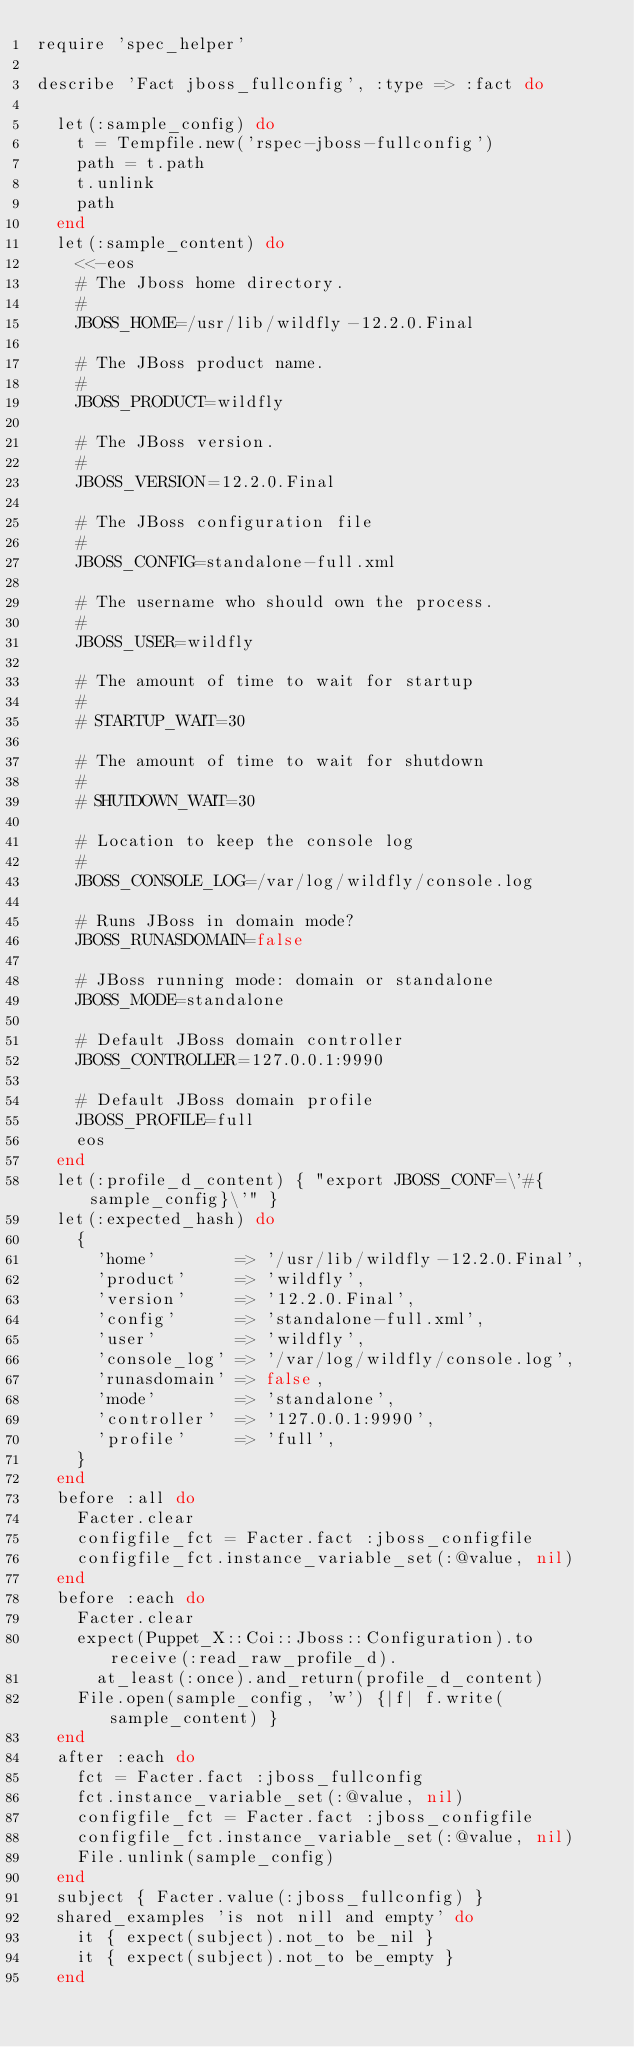<code> <loc_0><loc_0><loc_500><loc_500><_Ruby_>require 'spec_helper'

describe 'Fact jboss_fullconfig', :type => :fact do

  let(:sample_config) do
    t = Tempfile.new('rspec-jboss-fullconfig')
    path = t.path
    t.unlink
    path
  end
  let(:sample_content) do
    <<-eos
    # The Jboss home directory.
    #
    JBOSS_HOME=/usr/lib/wildfly-12.2.0.Final

    # The JBoss product name.
    #
    JBOSS_PRODUCT=wildfly

    # The JBoss version.
    #
    JBOSS_VERSION=12.2.0.Final

    # The JBoss configuration file
    #
    JBOSS_CONFIG=standalone-full.xml

    # The username who should own the process.
    #
    JBOSS_USER=wildfly

    # The amount of time to wait for startup
    #
    # STARTUP_WAIT=30

    # The amount of time to wait for shutdown
    #
    # SHUTDOWN_WAIT=30

    # Location to keep the console log
    #
    JBOSS_CONSOLE_LOG=/var/log/wildfly/console.log

    # Runs JBoss in domain mode?
    JBOSS_RUNASDOMAIN=false

    # JBoss running mode: domain or standalone
    JBOSS_MODE=standalone

    # Default JBoss domain controller
    JBOSS_CONTROLLER=127.0.0.1:9990

    # Default JBoss domain profile
    JBOSS_PROFILE=full
    eos
  end
  let(:profile_d_content) { "export JBOSS_CONF=\'#{sample_config}\'" }
  let(:expected_hash) do
    {
      'home'        => '/usr/lib/wildfly-12.2.0.Final',
      'product'     => 'wildfly',
      'version'     => '12.2.0.Final',
      'config'      => 'standalone-full.xml',
      'user'        => 'wildfly',
      'console_log' => '/var/log/wildfly/console.log',
      'runasdomain' => false,
      'mode'        => 'standalone',
      'controller'  => '127.0.0.1:9990',
      'profile'     => 'full',
    }
  end
  before :all do
    Facter.clear
    configfile_fct = Facter.fact :jboss_configfile
    configfile_fct.instance_variable_set(:@value, nil)
  end
  before :each do
    Facter.clear
    expect(Puppet_X::Coi::Jboss::Configuration).to receive(:read_raw_profile_d).
      at_least(:once).and_return(profile_d_content)
    File.open(sample_config, 'w') {|f| f.write(sample_content) }
  end
  after :each do
    fct = Facter.fact :jboss_fullconfig
    fct.instance_variable_set(:@value, nil)
    configfile_fct = Facter.fact :jboss_configfile
    configfile_fct.instance_variable_set(:@value, nil)
    File.unlink(sample_config)
  end
  subject { Facter.value(:jboss_fullconfig) }
  shared_examples 'is not nill and empty' do
    it { expect(subject).not_to be_nil }
    it { expect(subject).not_to be_empty }
  end</code> 